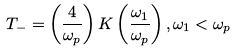<formula> <loc_0><loc_0><loc_500><loc_500>T _ { - } = \left ( \frac { 4 } { \omega _ { p } } \right ) K \left ( \frac { \omega _ { 1 } } { \omega _ { p } } \right ) , \omega _ { 1 } < \omega _ { p }</formula> 